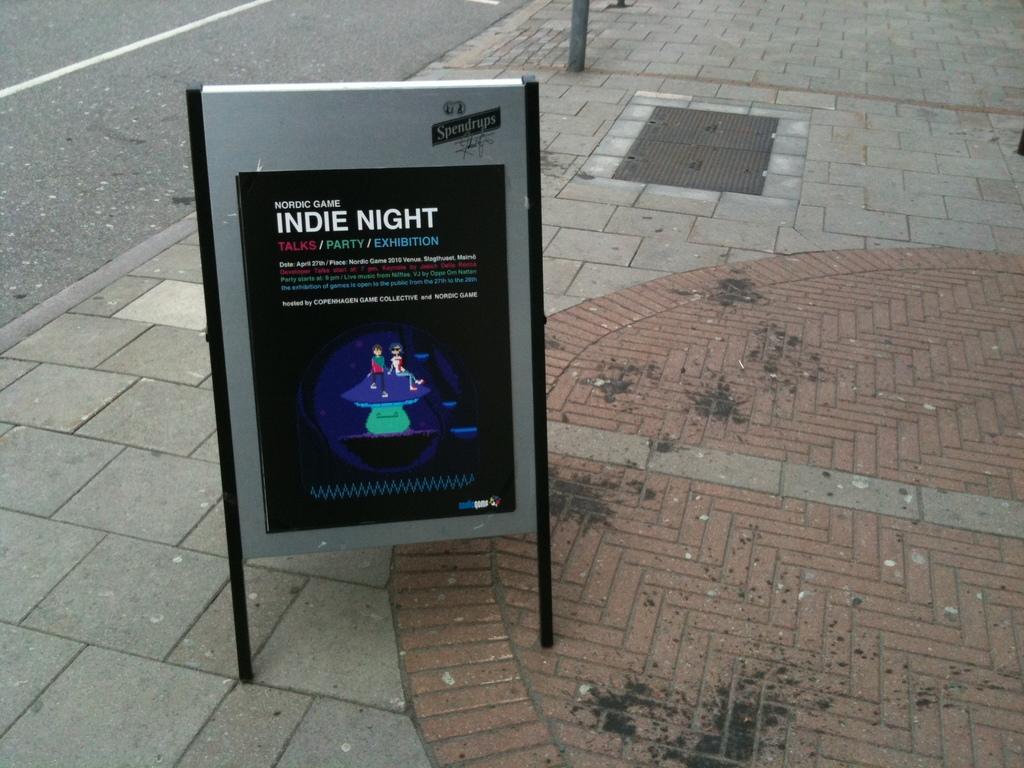What night is it?
Give a very brief answer. Indie. What kind of event is on the board?
Provide a succinct answer. Indie night. 